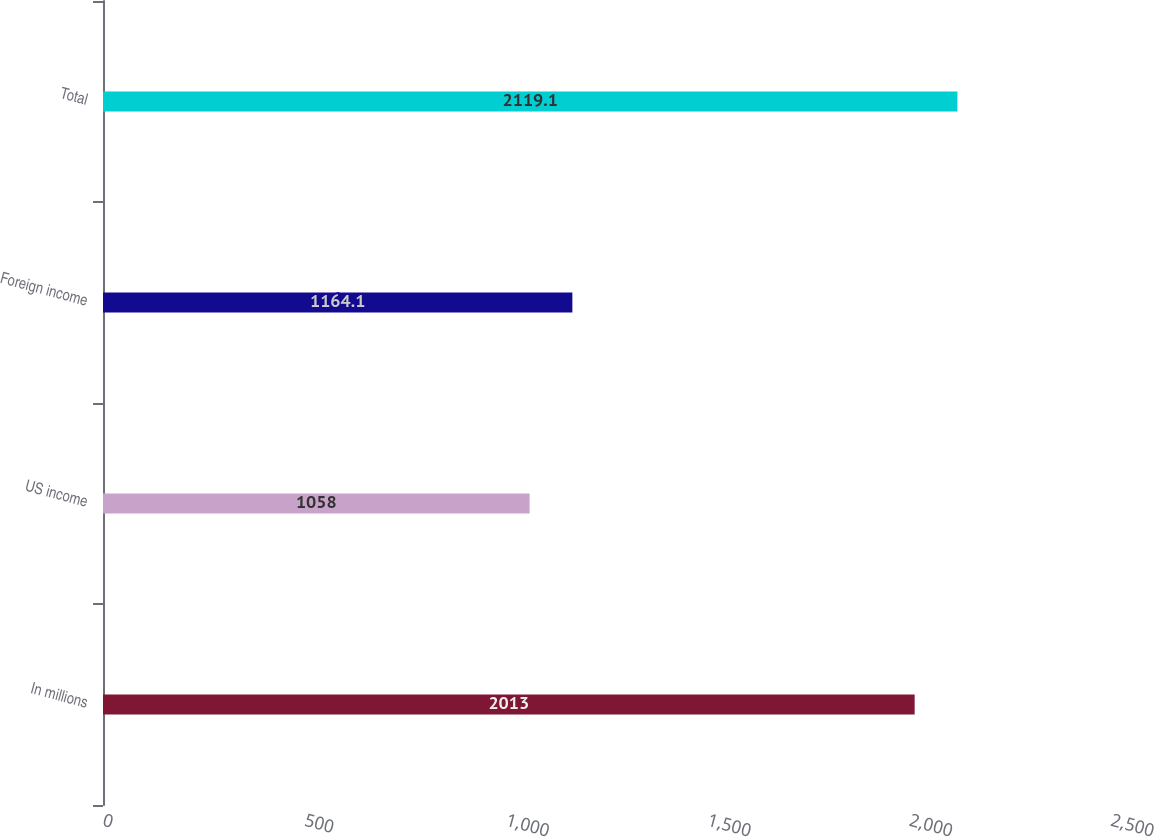Convert chart to OTSL. <chart><loc_0><loc_0><loc_500><loc_500><bar_chart><fcel>In millions<fcel>US income<fcel>Foreign income<fcel>Total<nl><fcel>2013<fcel>1058<fcel>1164.1<fcel>2119.1<nl></chart> 